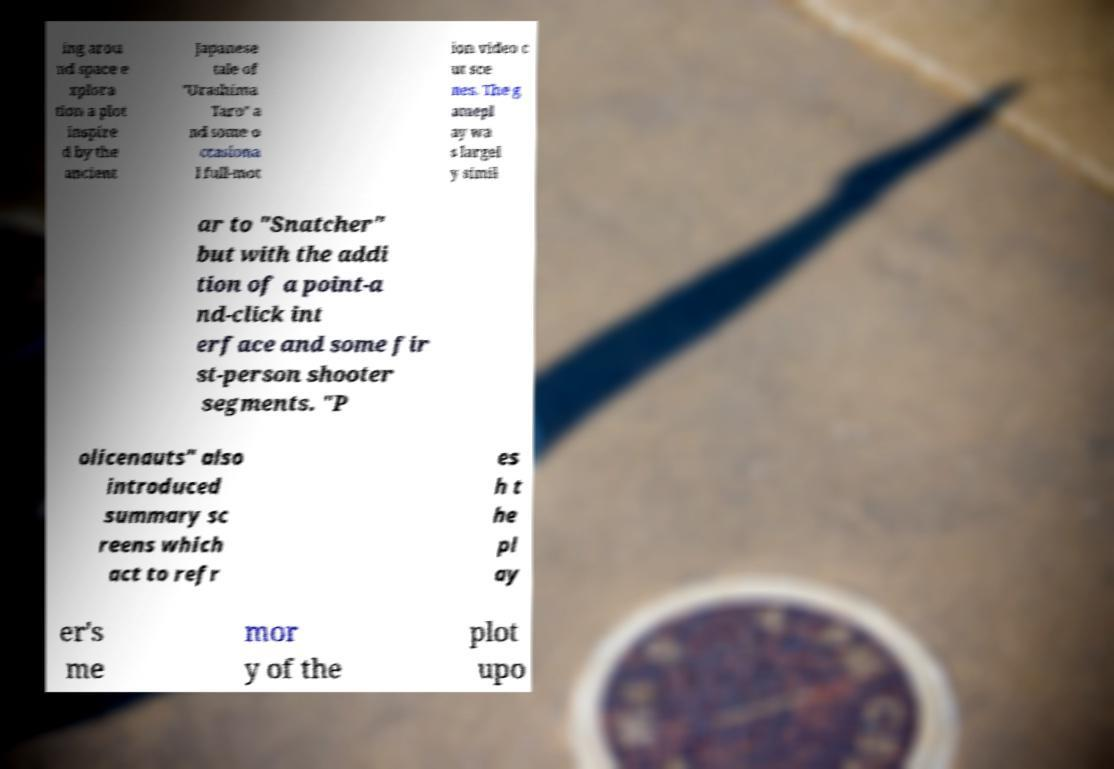Can you accurately transcribe the text from the provided image for me? ing arou nd space e xplora tion a plot inspire d by the ancient Japanese tale of "Urashima Taro" a nd some o ccasiona l full-mot ion video c ut sce nes. The g amepl ay wa s largel y simil ar to "Snatcher" but with the addi tion of a point-a nd-click int erface and some fir st-person shooter segments. "P olicenauts" also introduced summary sc reens which act to refr es h t he pl ay er's me mor y of the plot upo 